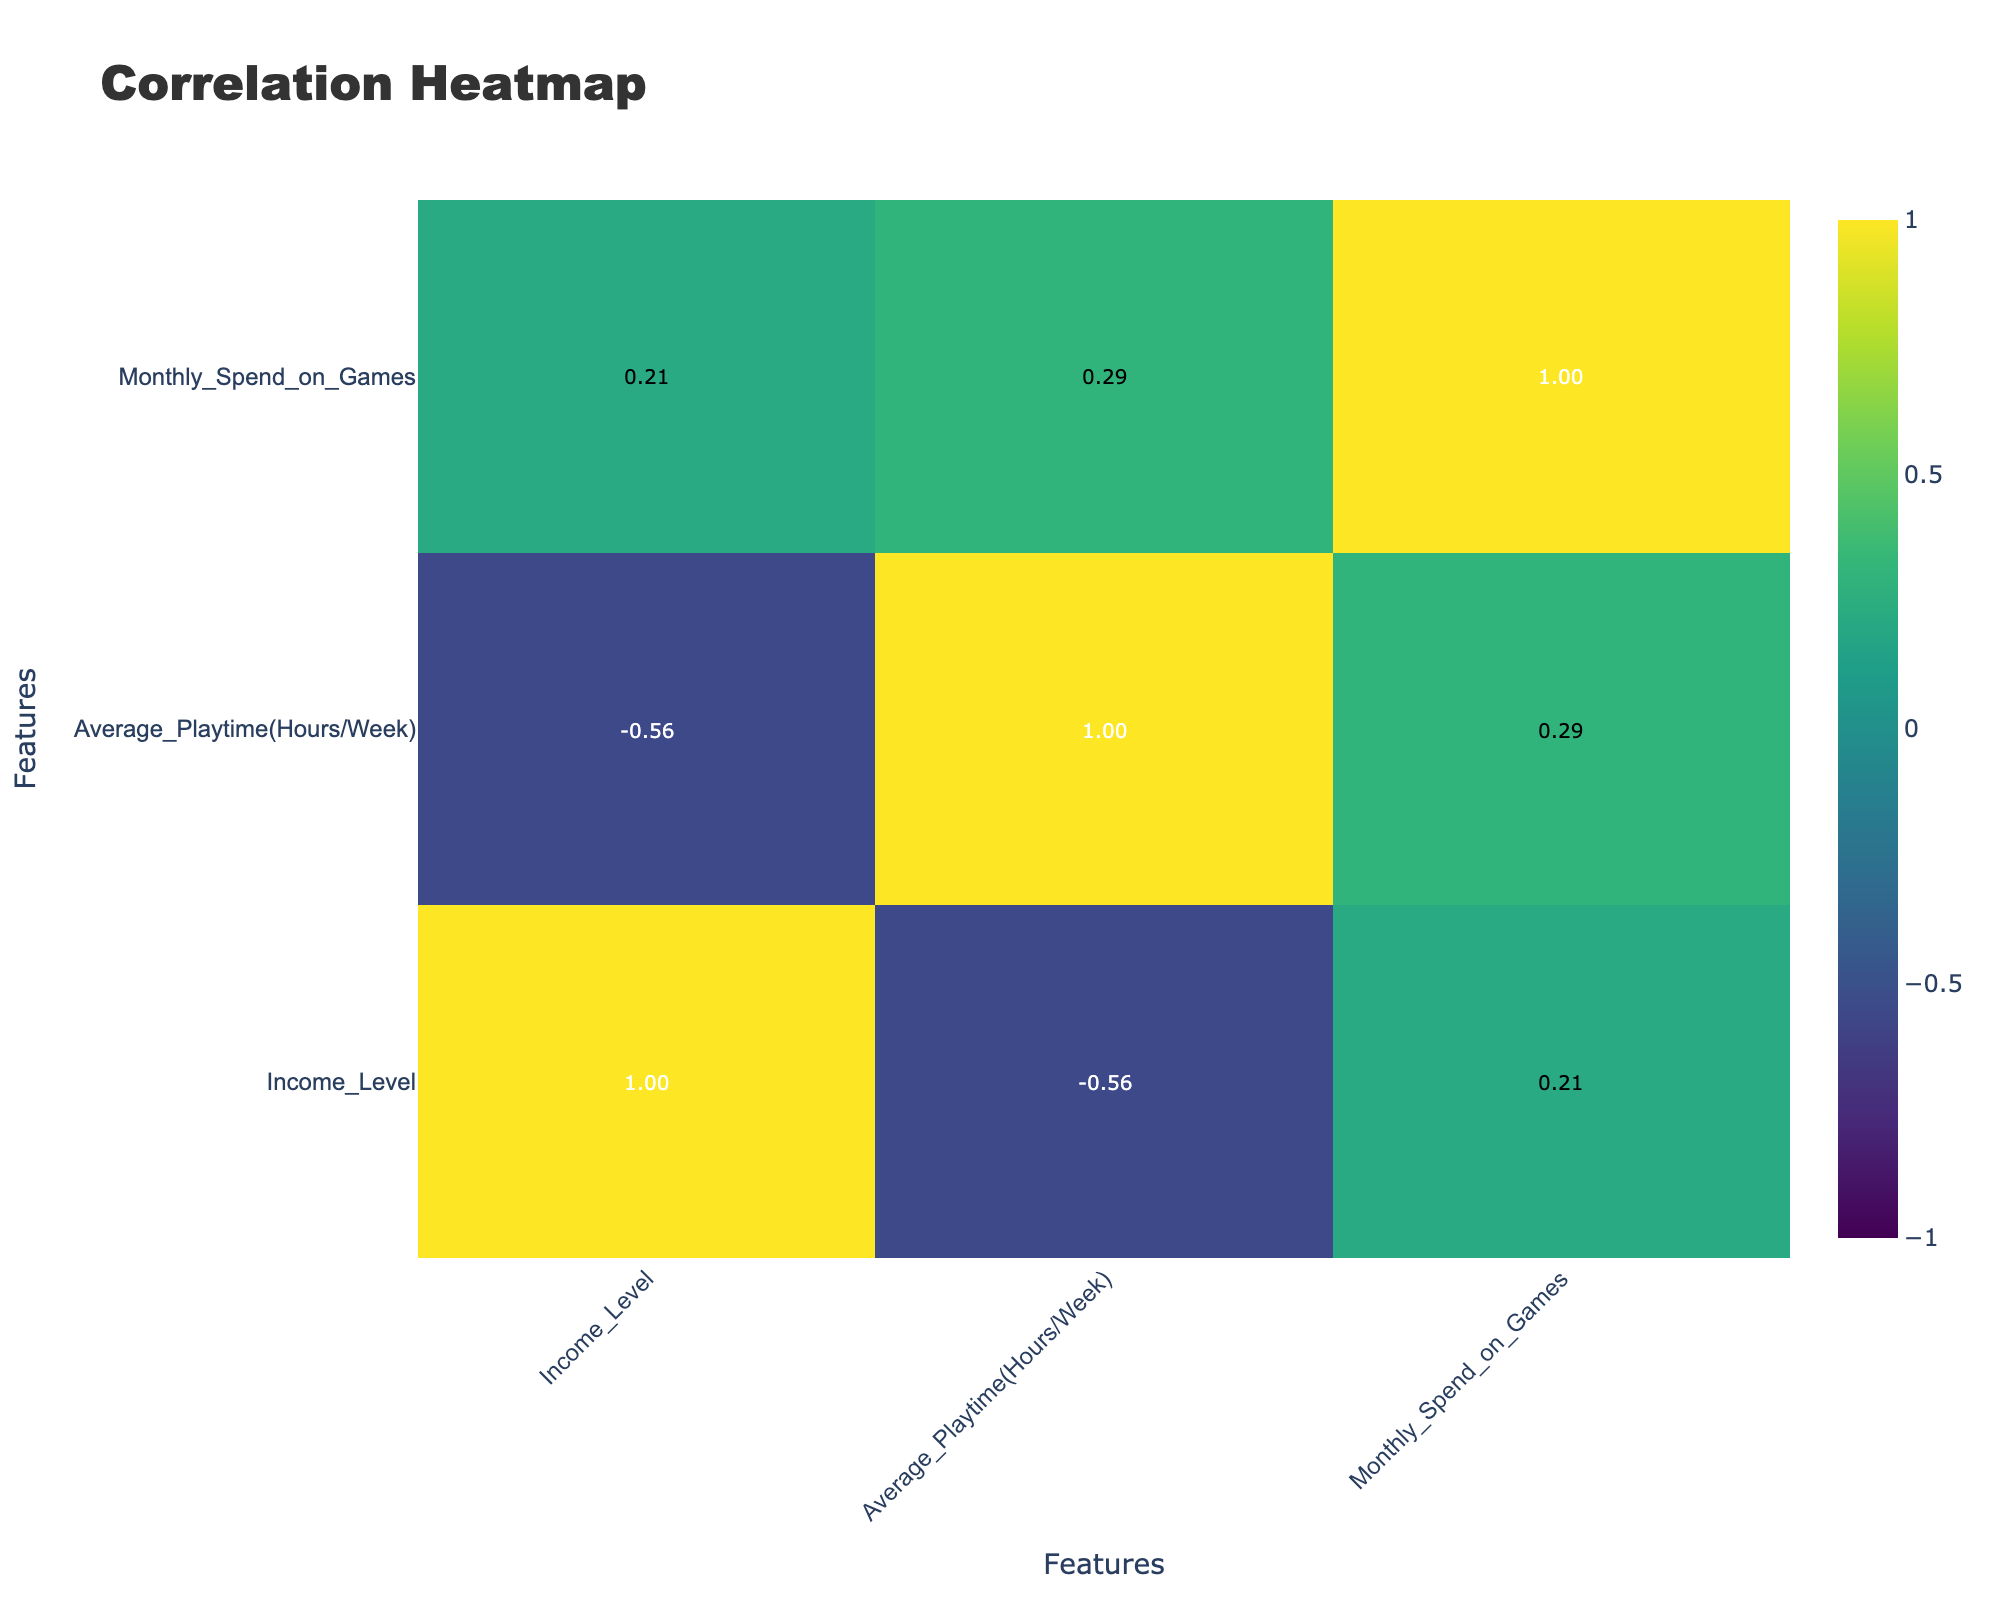What is the correlation between Average Playtime and Monthly Spend on Games? The correlation value in the table shows how closely linked Average Playtime (Hours/Week) and Monthly Spend on Games are. Upon checking the correlation table, the correlation value found is 0.10, indicating a very weak positive relationship between average playtime and monthly spending on games.
Answer: 0.10 Are females more likely to spend more on games compared to males? To determine this, you can average the Monthly Spend on Games by gender. For females, the amounts are 30, 60, 45, and 35 giving an average of (30 + 60 + 45 + 35) / 4 = 42.5. For males, the amounts are 50, 100, 40, 25, 80 giving an average of (50 + 100 + 40 + 25 + 80) / 5 = 59. The gender average indicates that males spend more on games than females.
Answer: No What is the average Monthly Spend on Games for the age group 18-24? For the age group 18-24, the Monthly Spend on Games values are 50, 60, 25. Calculating the average gives (50 + 60 + 25) / 3 = 45. Thus, the average Monthly Spend for this age group is 45.
Answer: 45 Do players aged 35-44 have a higher average playtime than those aged 25-34? For age group 35-44, the Average Playtime values are 12, 5, 10 which averages to (12 + 5 + 10) / 3 = 9. For age group 25-34, the values are 10, 25, 15, 12, which averages to (10 + 25 + 15 + 12) / 4 = 15. Comparing the two, since 9 < 15, players aged 35-44 do not have a higher average playtime than those aged 25-34.
Answer: No Is there a noticeable trend in Monthly Spend on Games with respect to income level? To analyze the trend, looking at the correlation value of Monthly Spend on Games and Income Level is necessary. The correlation value is found to be approximately 0.80, indicating a strong positive relationship, meaning as income level increases, spending on games tends to increase.
Answer: Yes 